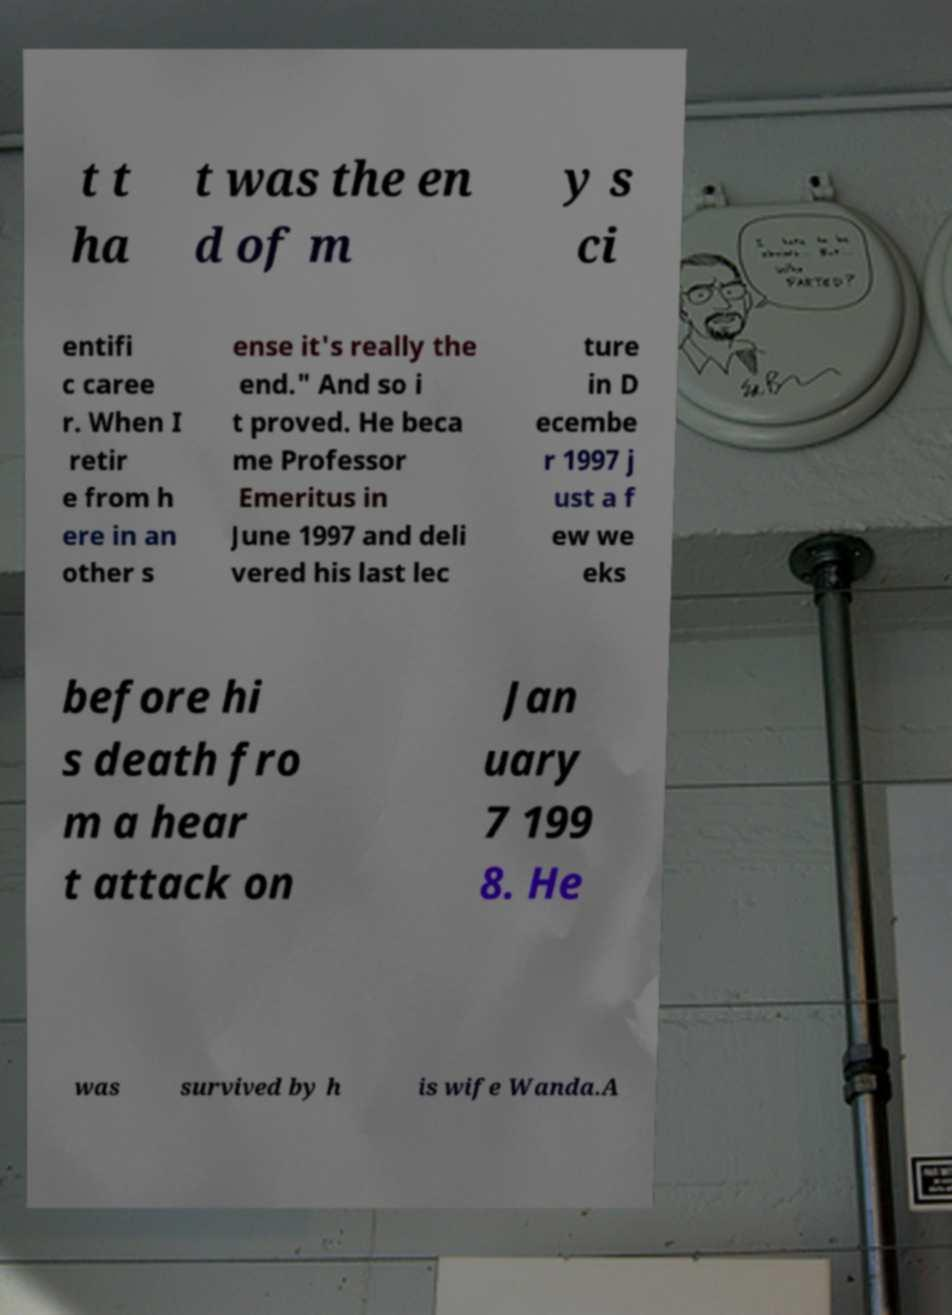Can you read and provide the text displayed in the image?This photo seems to have some interesting text. Can you extract and type it out for me? t t ha t was the en d of m y s ci entifi c caree r. When I retir e from h ere in an other s ense it's really the end." And so i t proved. He beca me Professor Emeritus in June 1997 and deli vered his last lec ture in D ecembe r 1997 j ust a f ew we eks before hi s death fro m a hear t attack on Jan uary 7 199 8. He was survived by h is wife Wanda.A 